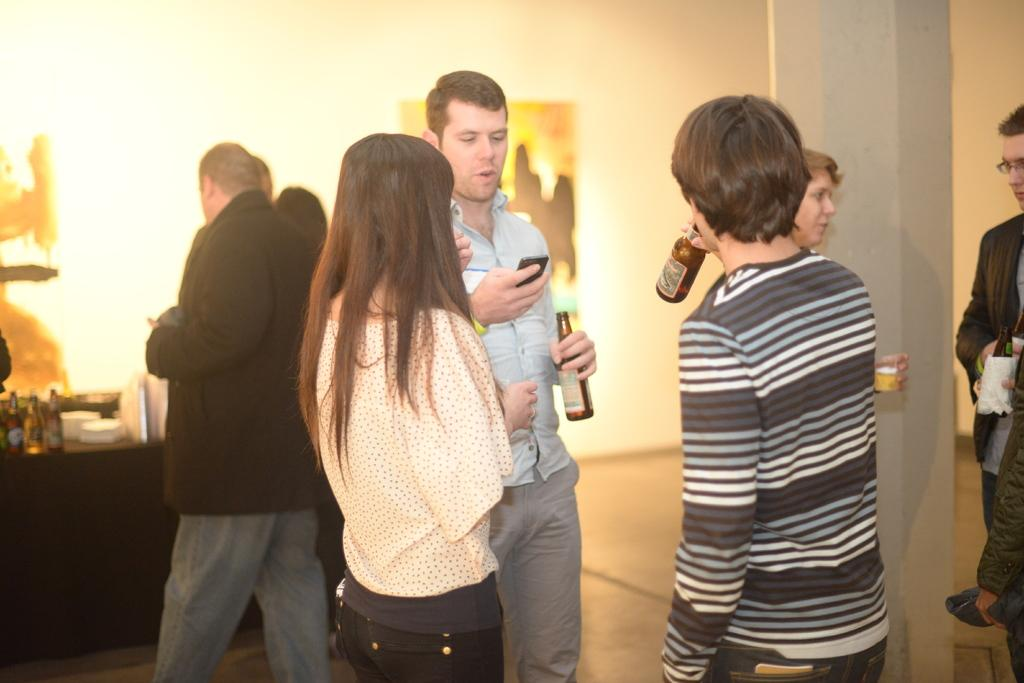What is happening in the image? There are people standing in the image. Can you describe the person on the right side of the image? The person on the right side is holding a bottle. What type of plants are being exchanged between the family members in the image? There is no mention of plants or family members in the image, so it cannot be determined if any plants are being exchanged. 